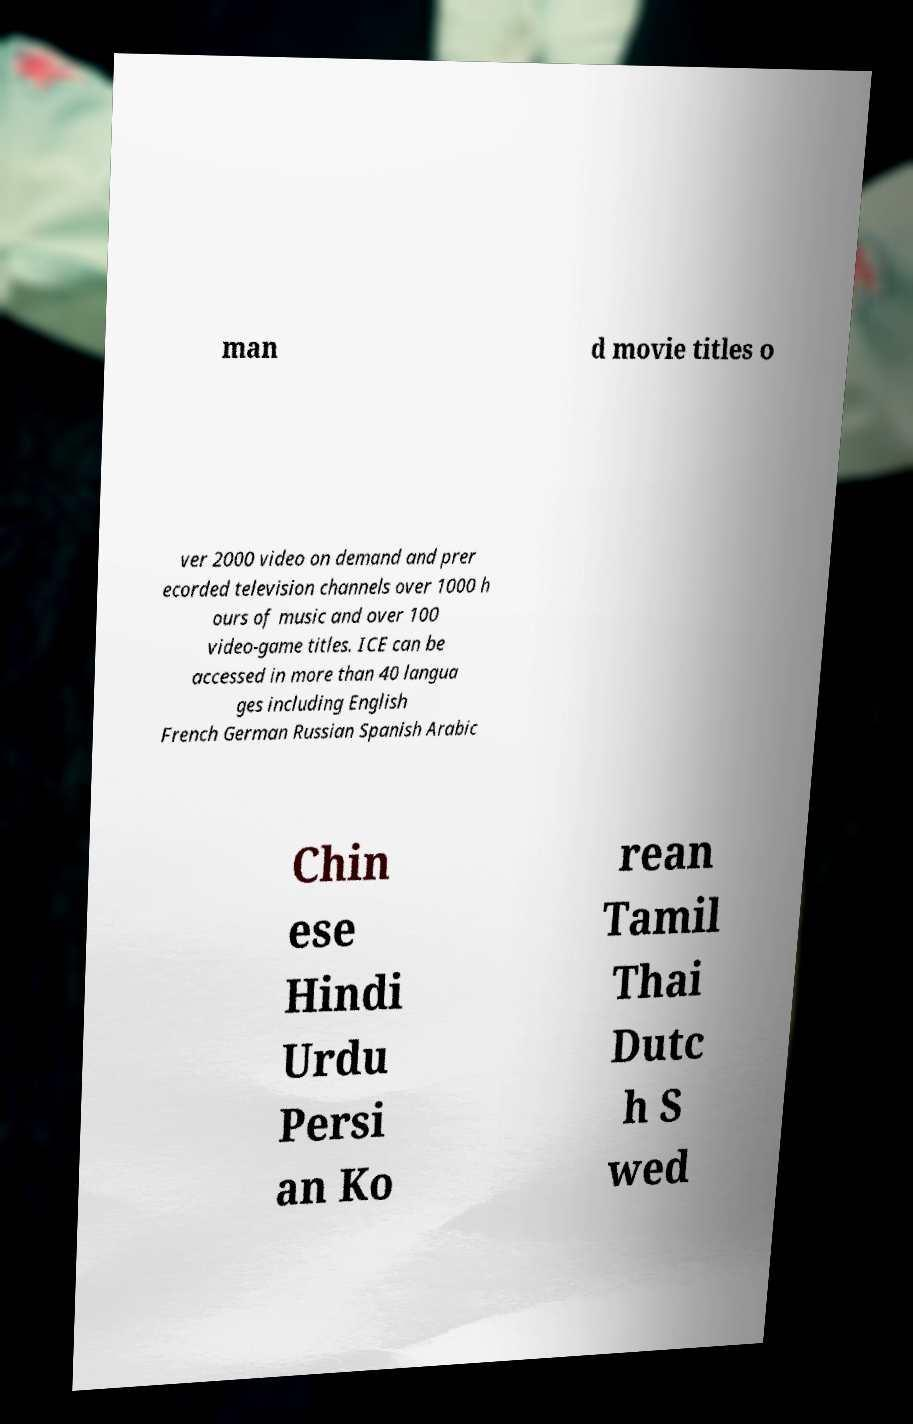For documentation purposes, I need the text within this image transcribed. Could you provide that? man d movie titles o ver 2000 video on demand and prer ecorded television channels over 1000 h ours of music and over 100 video-game titles. ICE can be accessed in more than 40 langua ges including English French German Russian Spanish Arabic Chin ese Hindi Urdu Persi an Ko rean Tamil Thai Dutc h S wed 